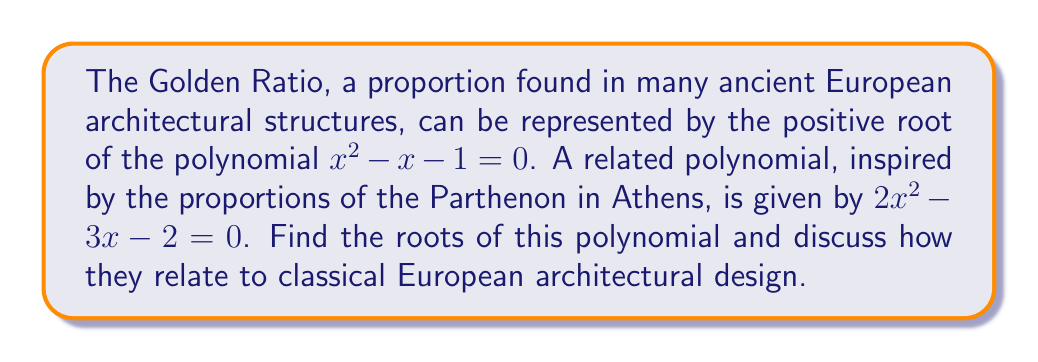Can you solve this math problem? To find the roots of the polynomial $2x^2 - 3x - 2 = 0$, we'll use the quadratic formula:

$$x = \frac{-b \pm \sqrt{b^2 - 4ac}}{2a}$$

Where $a = 2$, $b = -3$, and $c = -2$.

Substituting these values:

$$x = \frac{3 \pm \sqrt{(-3)^2 - 4(2)(-2)}}{2(2)}$$
$$x = \frac{3 \pm \sqrt{9 + 16}}{4}$$
$$x = \frac{3 \pm \sqrt{25}}{4}$$
$$x = \frac{3 \pm 5}{4}$$

This gives us two roots:

$$x_1 = \frac{3 + 5}{4} = \frac{8}{4} = 2$$
$$x_2 = \frac{3 - 5}{4} = -\frac{1}{2} = -0.5$$

The positive root, 2, is particularly interesting in the context of classical European architecture. Many ancient Greek and Roman structures, including the Parthenon, used a ratio of 2:1 in their designs. This ratio was considered aesthetically pleasing and was often used in the proportions of columns, pediments, and overall building dimensions.

The negative root, -0.5, while not directly applicable to architectural proportions, still holds mathematical significance as it completes the solution set for the polynomial.

It's worth noting that this polynomial, while inspired by classical proportions, is not the Golden Ratio polynomial. The Golden Ratio, approximately 1.618, is the positive root of $x^2 - x - 1 = 0$. However, both the 2:1 ratio and the Golden Ratio were fundamental to ancient European architectural design, representing the classical ideals of balance, harmony, and beauty.
Answer: The roots of the polynomial $2x^2 - 3x - 2 = 0$ are $x_1 = 2$ and $x_2 = -0.5$. The positive root, 2, corresponds to the 2:1 ratio often used in classical European architecture, particularly in Greek designs like the Parthenon. 